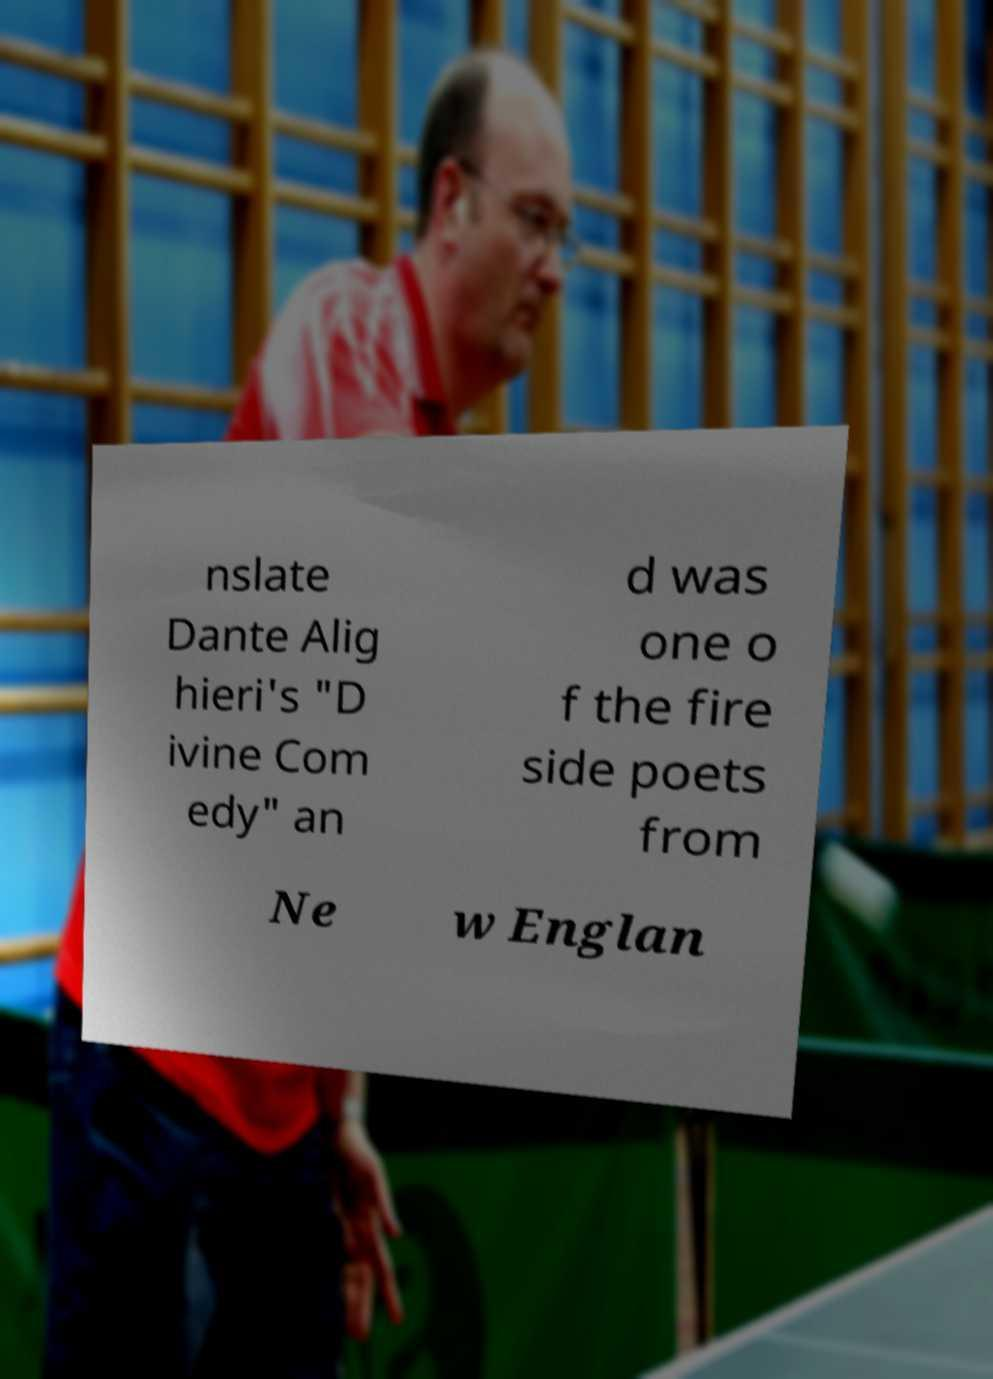For documentation purposes, I need the text within this image transcribed. Could you provide that? nslate Dante Alig hieri's "D ivine Com edy" an d was one o f the fire side poets from Ne w Englan 